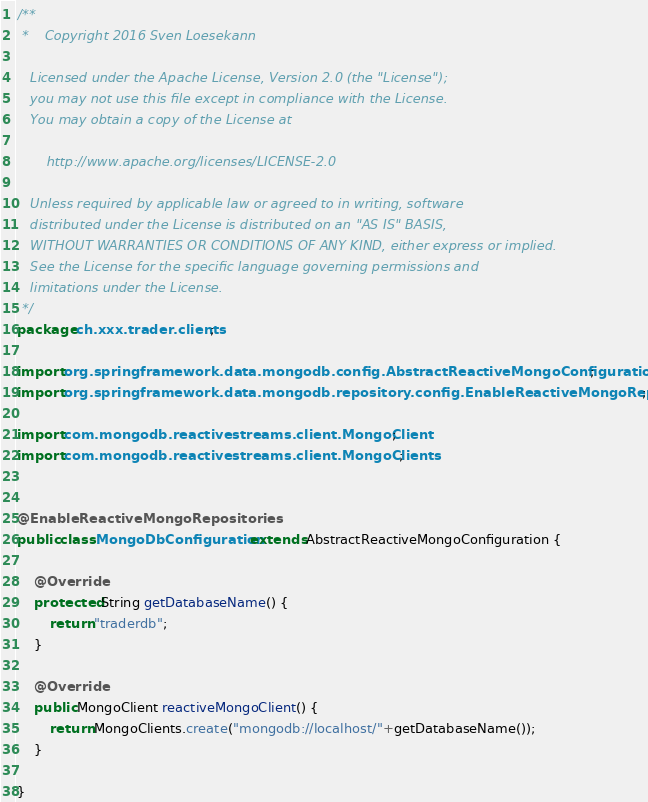<code> <loc_0><loc_0><loc_500><loc_500><_Java_>/**
 *    Copyright 2016 Sven Loesekann

   Licensed under the Apache License, Version 2.0 (the "License");
   you may not use this file except in compliance with the License.
   You may obtain a copy of the License at

       http://www.apache.org/licenses/LICENSE-2.0

   Unless required by applicable law or agreed to in writing, software
   distributed under the License is distributed on an "AS IS" BASIS,
   WITHOUT WARRANTIES OR CONDITIONS OF ANY KIND, either express or implied.
   See the License for the specific language governing permissions and
   limitations under the License.
 */
package ch.xxx.trader.clients;

import org.springframework.data.mongodb.config.AbstractReactiveMongoConfiguration;
import org.springframework.data.mongodb.repository.config.EnableReactiveMongoRepositories;

import com.mongodb.reactivestreams.client.MongoClient;
import com.mongodb.reactivestreams.client.MongoClients;


@EnableReactiveMongoRepositories
public class MongoDbConfiguration extends AbstractReactiveMongoConfiguration {

	@Override
	protected String getDatabaseName() {
		return "traderdb";
	}

	@Override
	public MongoClient reactiveMongoClient() {
		return MongoClients.create("mongodb://localhost/"+getDatabaseName());
	}

}
</code> 